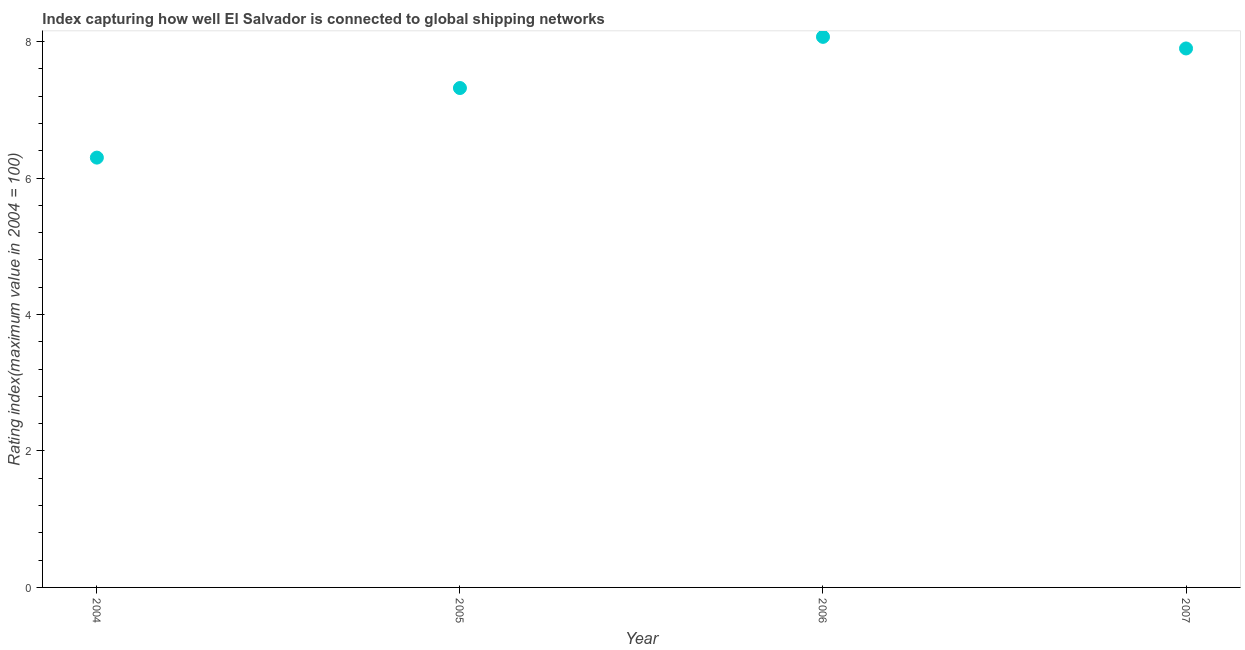What is the liner shipping connectivity index in 2007?
Provide a short and direct response. 7.9. Across all years, what is the maximum liner shipping connectivity index?
Make the answer very short. 8.07. In which year was the liner shipping connectivity index maximum?
Ensure brevity in your answer.  2006. In which year was the liner shipping connectivity index minimum?
Your answer should be compact. 2004. What is the sum of the liner shipping connectivity index?
Keep it short and to the point. 29.59. What is the difference between the liner shipping connectivity index in 2004 and 2006?
Your answer should be compact. -1.77. What is the average liner shipping connectivity index per year?
Give a very brief answer. 7.4. What is the median liner shipping connectivity index?
Ensure brevity in your answer.  7.61. Do a majority of the years between 2006 and 2004 (inclusive) have liner shipping connectivity index greater than 2.4 ?
Provide a short and direct response. No. What is the ratio of the liner shipping connectivity index in 2005 to that in 2007?
Your answer should be compact. 0.93. Is the liner shipping connectivity index in 2005 less than that in 2006?
Offer a terse response. Yes. Is the difference between the liner shipping connectivity index in 2004 and 2007 greater than the difference between any two years?
Make the answer very short. No. What is the difference between the highest and the second highest liner shipping connectivity index?
Offer a terse response. 0.17. What is the difference between the highest and the lowest liner shipping connectivity index?
Your answer should be very brief. 1.77. How many dotlines are there?
Your answer should be very brief. 1. How many years are there in the graph?
Offer a very short reply. 4. What is the difference between two consecutive major ticks on the Y-axis?
Make the answer very short. 2. Are the values on the major ticks of Y-axis written in scientific E-notation?
Your response must be concise. No. Does the graph contain grids?
Your answer should be compact. No. What is the title of the graph?
Keep it short and to the point. Index capturing how well El Salvador is connected to global shipping networks. What is the label or title of the X-axis?
Give a very brief answer. Year. What is the label or title of the Y-axis?
Keep it short and to the point. Rating index(maximum value in 2004 = 100). What is the Rating index(maximum value in 2004 = 100) in 2004?
Your answer should be very brief. 6.3. What is the Rating index(maximum value in 2004 = 100) in 2005?
Your answer should be compact. 7.32. What is the Rating index(maximum value in 2004 = 100) in 2006?
Make the answer very short. 8.07. What is the Rating index(maximum value in 2004 = 100) in 2007?
Offer a very short reply. 7.9. What is the difference between the Rating index(maximum value in 2004 = 100) in 2004 and 2005?
Ensure brevity in your answer.  -1.02. What is the difference between the Rating index(maximum value in 2004 = 100) in 2004 and 2006?
Ensure brevity in your answer.  -1.77. What is the difference between the Rating index(maximum value in 2004 = 100) in 2004 and 2007?
Ensure brevity in your answer.  -1.6. What is the difference between the Rating index(maximum value in 2004 = 100) in 2005 and 2006?
Offer a very short reply. -0.75. What is the difference between the Rating index(maximum value in 2004 = 100) in 2005 and 2007?
Provide a short and direct response. -0.58. What is the difference between the Rating index(maximum value in 2004 = 100) in 2006 and 2007?
Keep it short and to the point. 0.17. What is the ratio of the Rating index(maximum value in 2004 = 100) in 2004 to that in 2005?
Ensure brevity in your answer.  0.86. What is the ratio of the Rating index(maximum value in 2004 = 100) in 2004 to that in 2006?
Offer a terse response. 0.78. What is the ratio of the Rating index(maximum value in 2004 = 100) in 2004 to that in 2007?
Keep it short and to the point. 0.8. What is the ratio of the Rating index(maximum value in 2004 = 100) in 2005 to that in 2006?
Offer a very short reply. 0.91. What is the ratio of the Rating index(maximum value in 2004 = 100) in 2005 to that in 2007?
Offer a terse response. 0.93. 